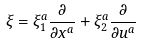<formula> <loc_0><loc_0><loc_500><loc_500>\xi = \xi _ { 1 } ^ { a } \frac { \partial } { \partial x ^ { a } } + \xi _ { 2 } ^ { a } \frac { \partial } { \partial u ^ { a } }</formula> 